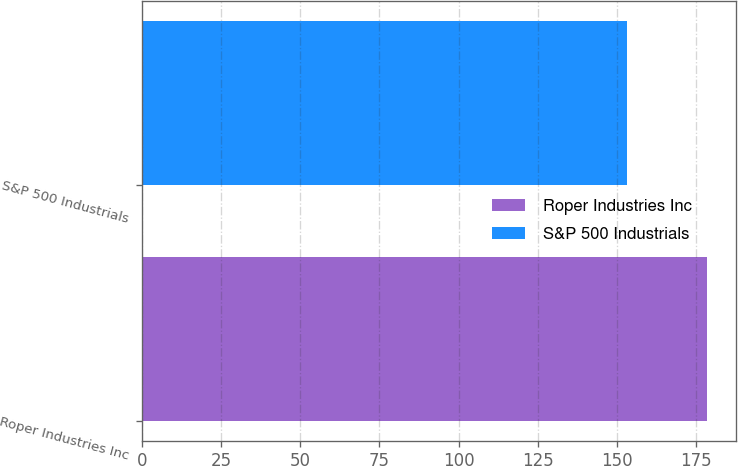Convert chart to OTSL. <chart><loc_0><loc_0><loc_500><loc_500><bar_chart><fcel>Roper Industries Inc<fcel>S&P 500 Industrials<nl><fcel>178.54<fcel>153.26<nl></chart> 